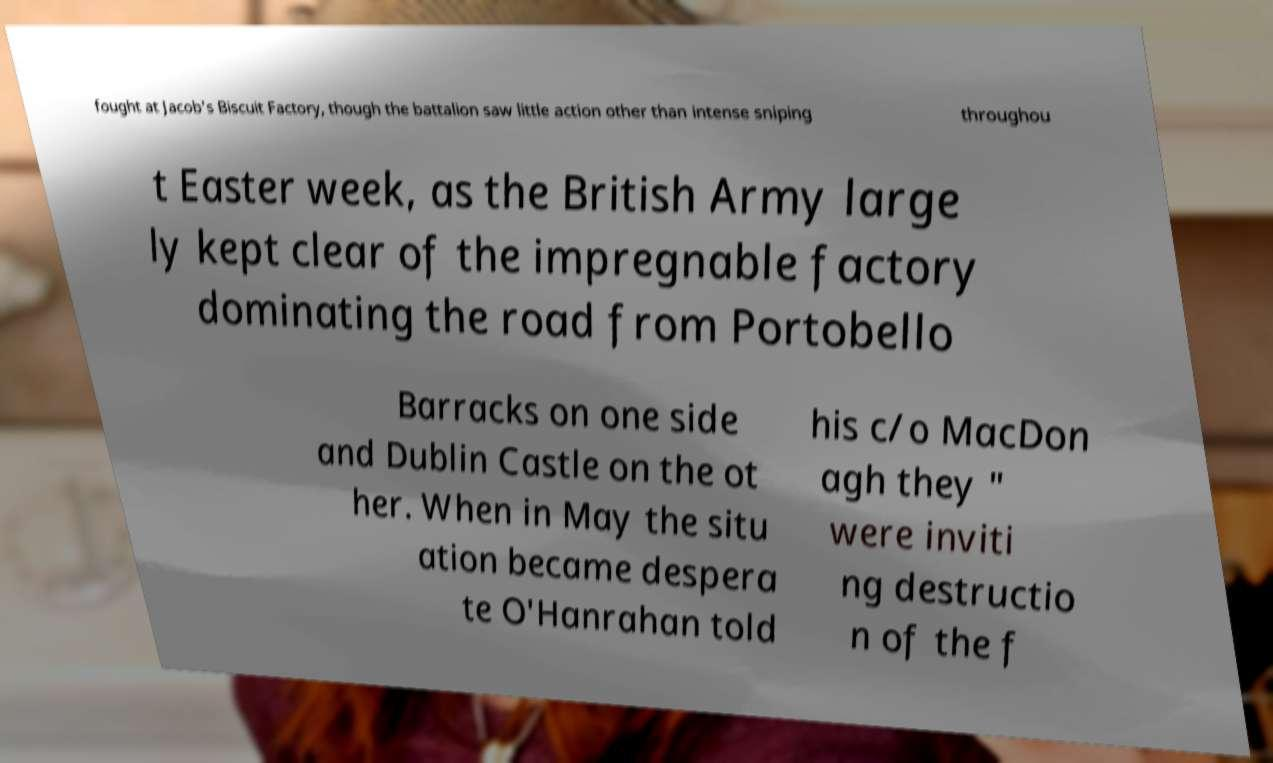For documentation purposes, I need the text within this image transcribed. Could you provide that? fought at Jacob's Biscuit Factory, though the battalion saw little action other than intense sniping throughou t Easter week, as the British Army large ly kept clear of the impregnable factory dominating the road from Portobello Barracks on one side and Dublin Castle on the ot her. When in May the situ ation became despera te O'Hanrahan told his c/o MacDon agh they " were inviti ng destructio n of the f 